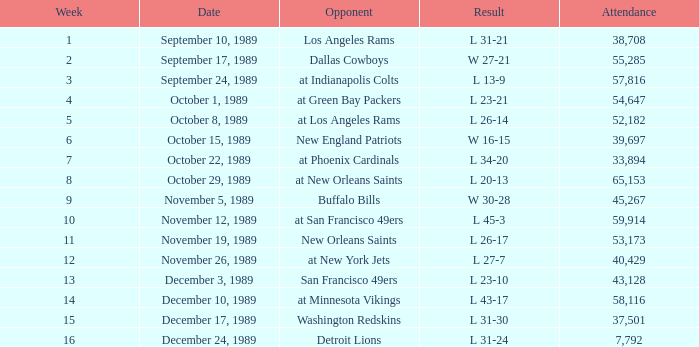What was the attendance count for the game on september 10, 1989? 38708.0. 